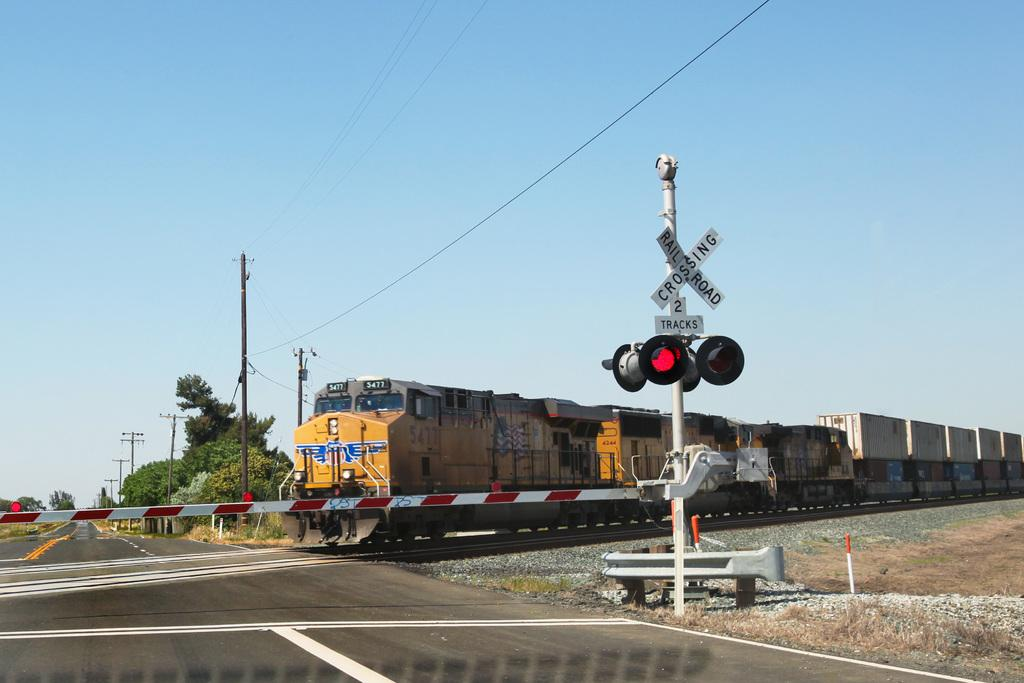<image>
Render a clear and concise summary of the photo. A railroad crossing sign says that there are two tracks at this spot. 